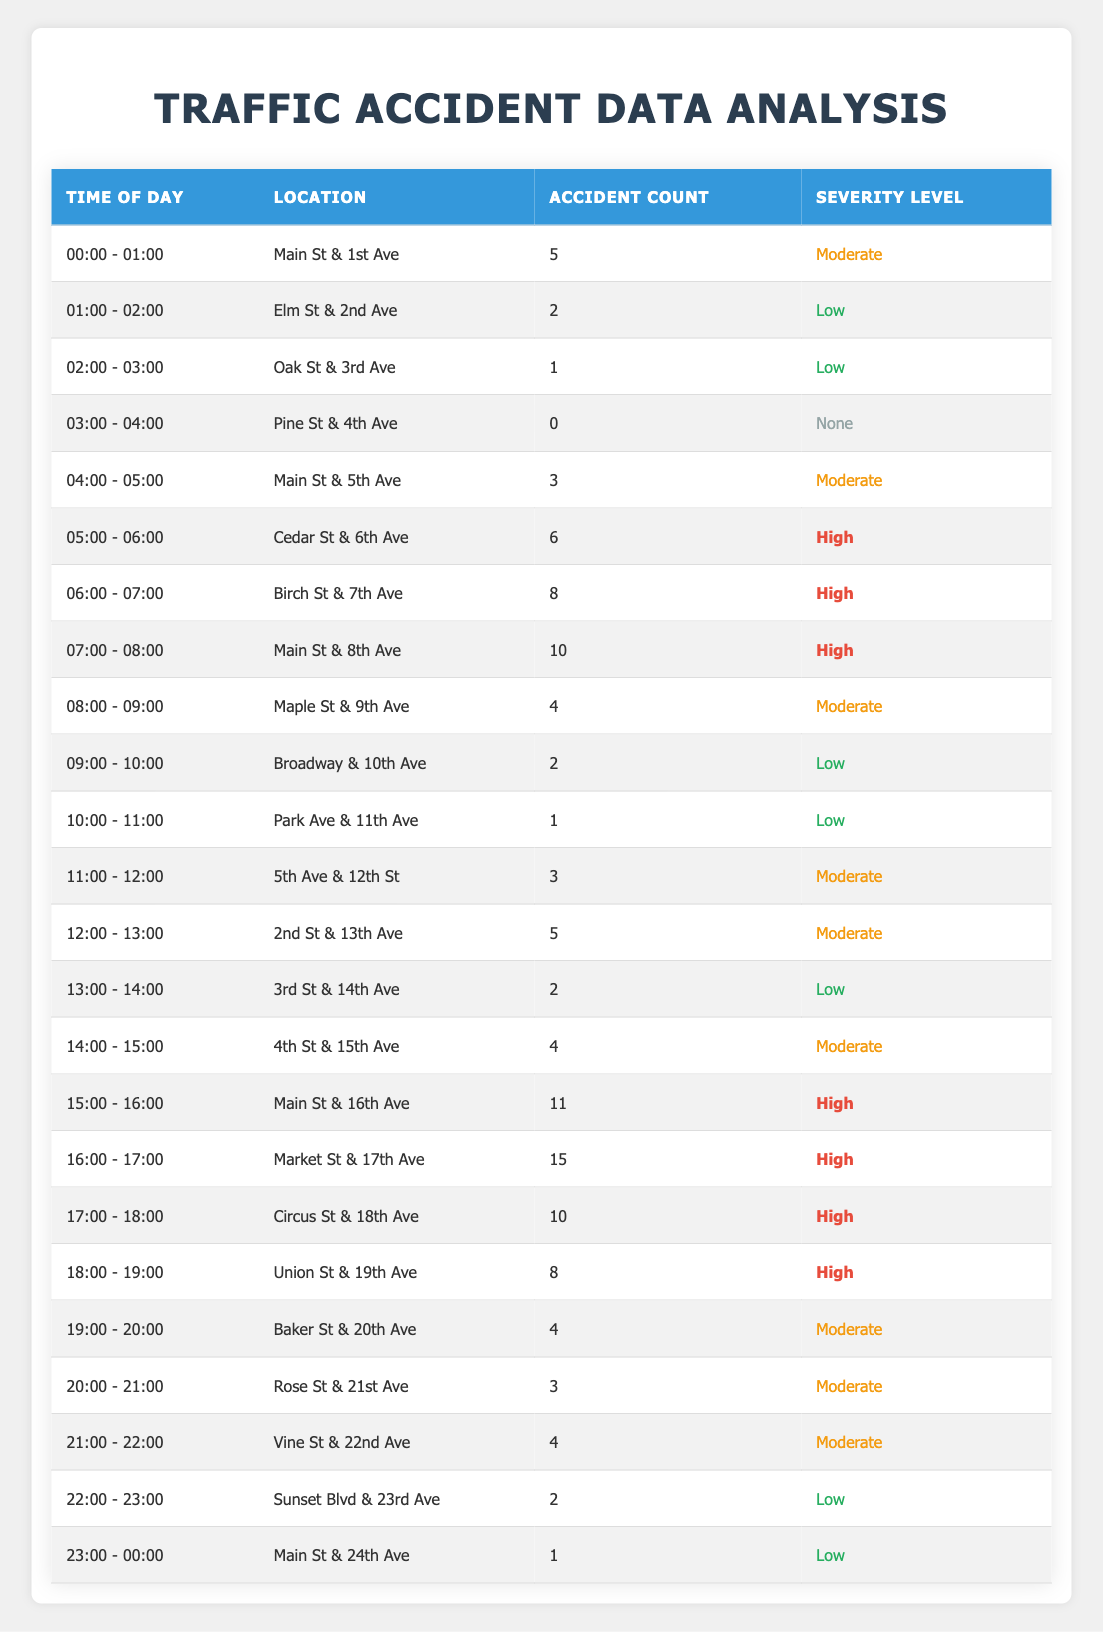What time of day had the highest number of accidents? The table shows the accident counts for each time segment. The highest count is 15 during the time 16:00 - 17:00.
Answer: 16:00 - 17:00 How many accidents occurred between 06:00 and 09:00? To find the total, add the accident counts from 06:00 - 07:00 (8), 07:00 - 08:00 (10), and 08:00 - 09:00 (4). So, 8 + 10 + 4 = 22.
Answer: 22 What is the severity level of accidents that occurred at Main St & 8th Ave? The table indicates that the location Main St & 8th Ave had 10 accidents with a severity level marked as High.
Answer: High Did any accidents occur between 03:00 and 04:00? The data shows that during 03:00 - 04:00, the accident count is 0, indicating no accidents happened during this time.
Answer: No Which location had the highest accident count and what was it? By reviewing the accident counts, Market St & 17th Ave had the highest number of accidents (15) during 16:00 - 17:00.
Answer: Market St & 17th Ave, 15 How many total 'High' severity accidents were reported in the table? Add all accidents with 'High' severity: Cedar St & 6th Ave (6), Birch St & 7th Ave (8), Main St & 8th Ave (10), Main St & 16th Ave (11), Market St & 17th Ave (15), Circus St & 18th Ave (10), and Union St & 19th Ave (8). So, 6 + 8 + 10 + 11 + 15 + 10 + 8 = 68.
Answer: 68 Which time period had the least number of accidents? The accident counts indicate that the time 02:00 - 03:00 had the least accidents with a count of 1.
Answer: 02:00 - 03:00 Was there ever a time with no accidents reported, and if so, when? Yes, during 03:00 - 04:00, the table states there were 0 accidents reported.
Answer: Yes, 03:00 - 04:00 What is the average number of accidents during the hours from 14:00 to 16:00? Accumulate the counts from 14:00 - 15:00 (4) and 15:00 - 16:00 (11). The total is 4 + 11 = 15. Divide by the number of time slots (2) gives an average of 15/2 = 7.5.
Answer: 7.5 How many 'Moderate' severity accidents occurred at the location Main St across different time periods? The table shows 3 accidents from 04:00 - 05:00, 10 from 07:00 - 08:00, and 11 from 15:00 - 16:00, totaling 3 + 3 = 6 'Moderate' incidents.
Answer: 6 